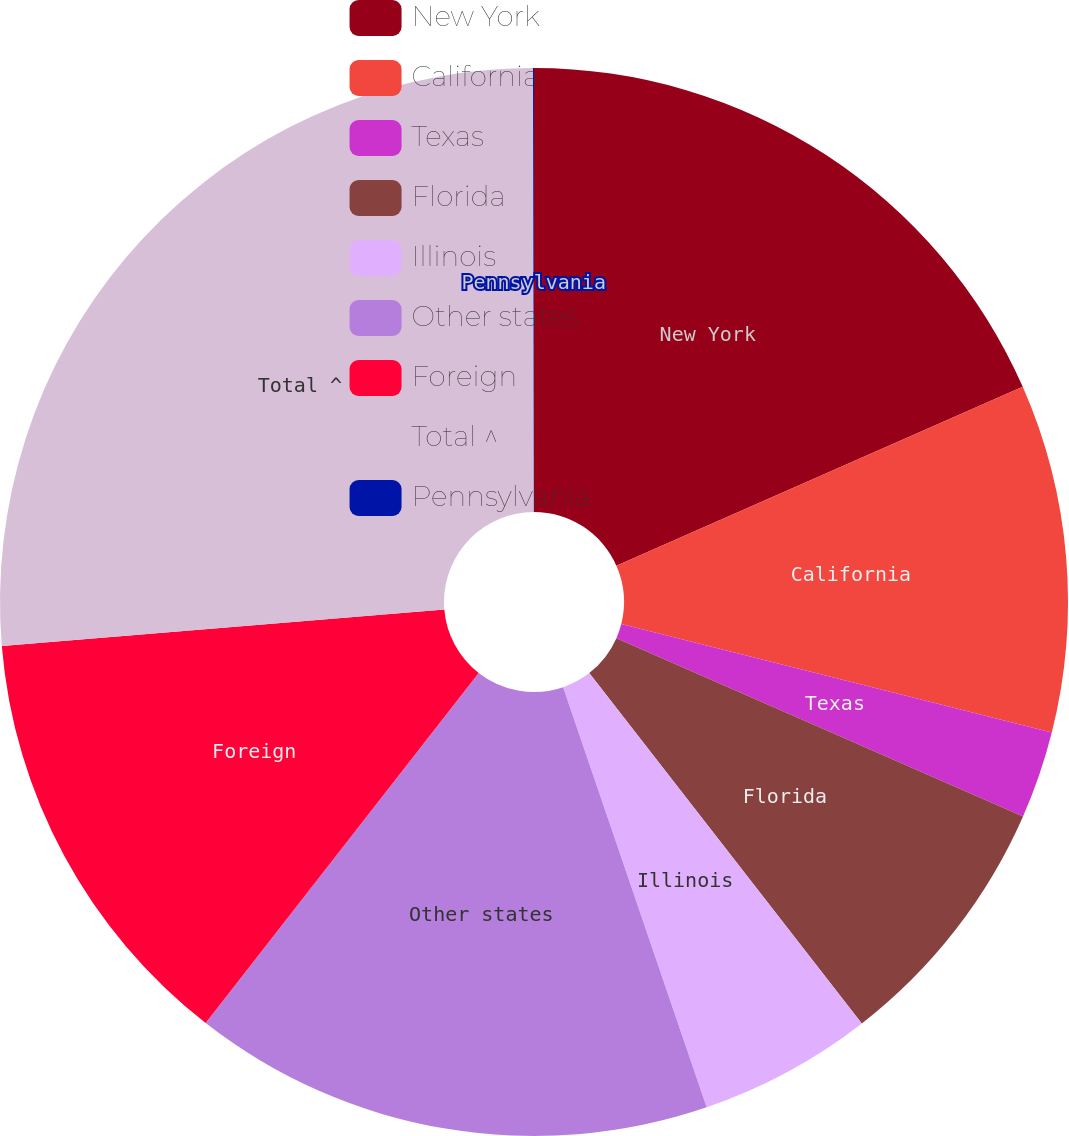<chart> <loc_0><loc_0><loc_500><loc_500><pie_chart><fcel>New York<fcel>California<fcel>Texas<fcel>Florida<fcel>Illinois<fcel>Other states<fcel>Foreign<fcel>Total ^<fcel>Pennsylvania<nl><fcel>18.4%<fcel>10.53%<fcel>2.65%<fcel>7.9%<fcel>5.28%<fcel>15.78%<fcel>13.15%<fcel>26.28%<fcel>0.03%<nl></chart> 